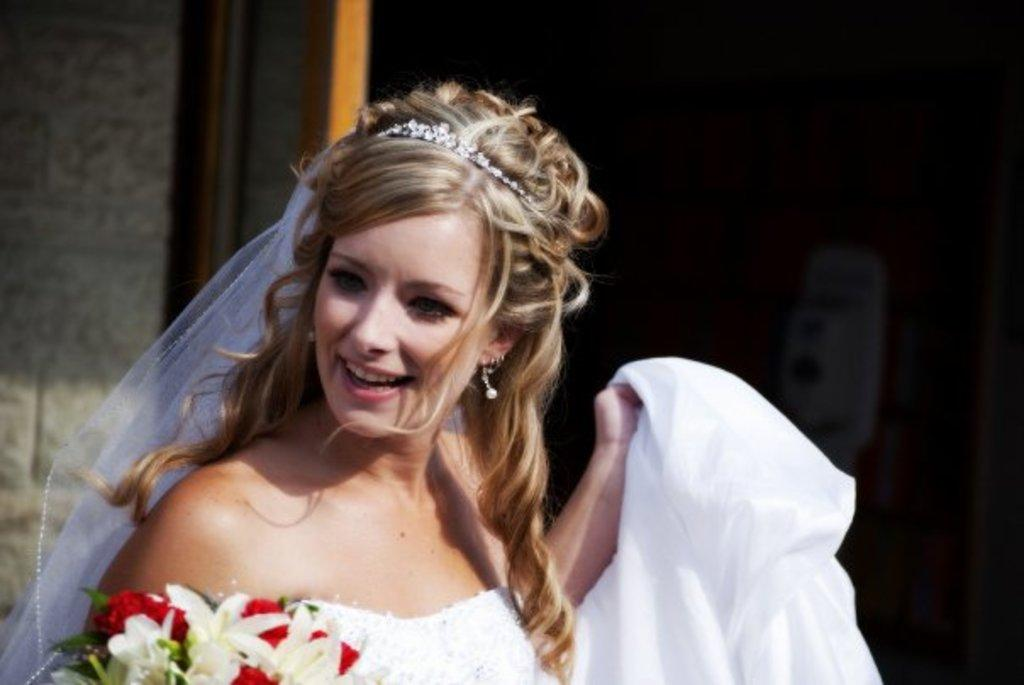What is the main subject of the image? There is a person in the image. Can you describe the person's appearance? The person is wearing clothes. What can be observed about the background of the image? The background of the image is blurred. What type of cracker is the person holding in the image? There is no cracker present in the image. Can you explain the magic trick being performed by the person in the image? There is no magic trick being performed in the image; the person is simply standing there wearing clothes. 